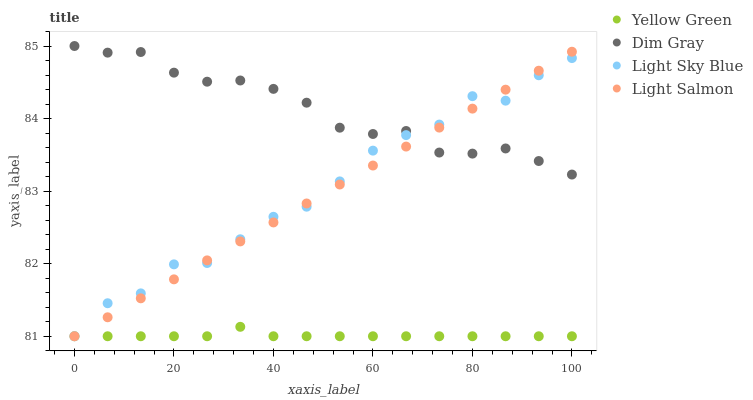Does Yellow Green have the minimum area under the curve?
Answer yes or no. Yes. Does Dim Gray have the maximum area under the curve?
Answer yes or no. Yes. Does Dim Gray have the minimum area under the curve?
Answer yes or no. No. Does Yellow Green have the maximum area under the curve?
Answer yes or no. No. Is Light Salmon the smoothest?
Answer yes or no. Yes. Is Light Sky Blue the roughest?
Answer yes or no. Yes. Is Dim Gray the smoothest?
Answer yes or no. No. Is Dim Gray the roughest?
Answer yes or no. No. Does Light Salmon have the lowest value?
Answer yes or no. Yes. Does Dim Gray have the lowest value?
Answer yes or no. No. Does Dim Gray have the highest value?
Answer yes or no. Yes. Does Yellow Green have the highest value?
Answer yes or no. No. Is Yellow Green less than Dim Gray?
Answer yes or no. Yes. Is Dim Gray greater than Yellow Green?
Answer yes or no. Yes. Does Dim Gray intersect Light Salmon?
Answer yes or no. Yes. Is Dim Gray less than Light Salmon?
Answer yes or no. No. Is Dim Gray greater than Light Salmon?
Answer yes or no. No. Does Yellow Green intersect Dim Gray?
Answer yes or no. No. 